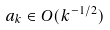Convert formula to latex. <formula><loc_0><loc_0><loc_500><loc_500>a _ { k } \in O ( k ^ { - 1 / 2 } )</formula> 